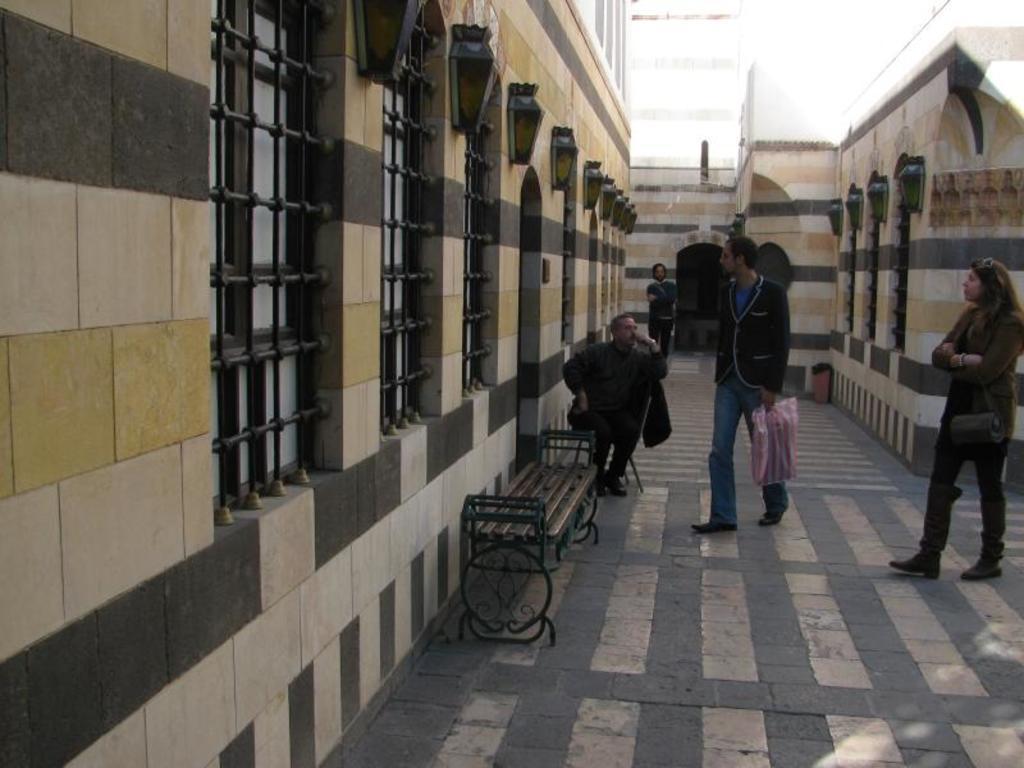Could you give a brief overview of what you see in this image? There are four people. In which three are men and one is woman. A man is standing at back and the other is walking towards a door. The third one is sitting beside it. 